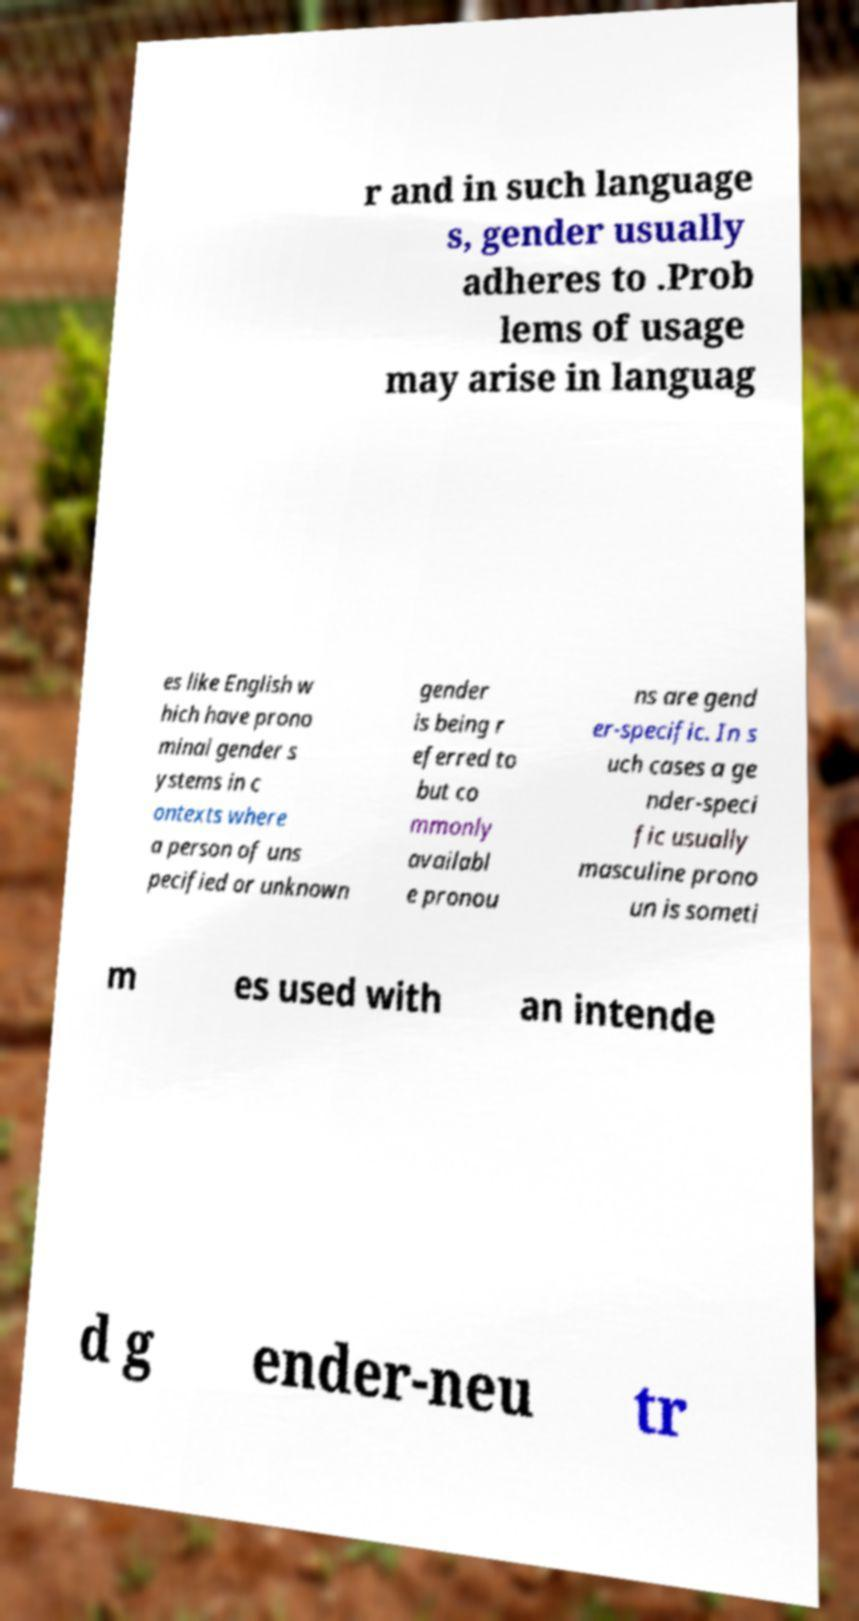What messages or text are displayed in this image? I need them in a readable, typed format. r and in such language s, gender usually adheres to .Prob lems of usage may arise in languag es like English w hich have prono minal gender s ystems in c ontexts where a person of uns pecified or unknown gender is being r eferred to but co mmonly availabl e pronou ns are gend er-specific. In s uch cases a ge nder-speci fic usually masculine prono un is someti m es used with an intende d g ender-neu tr 